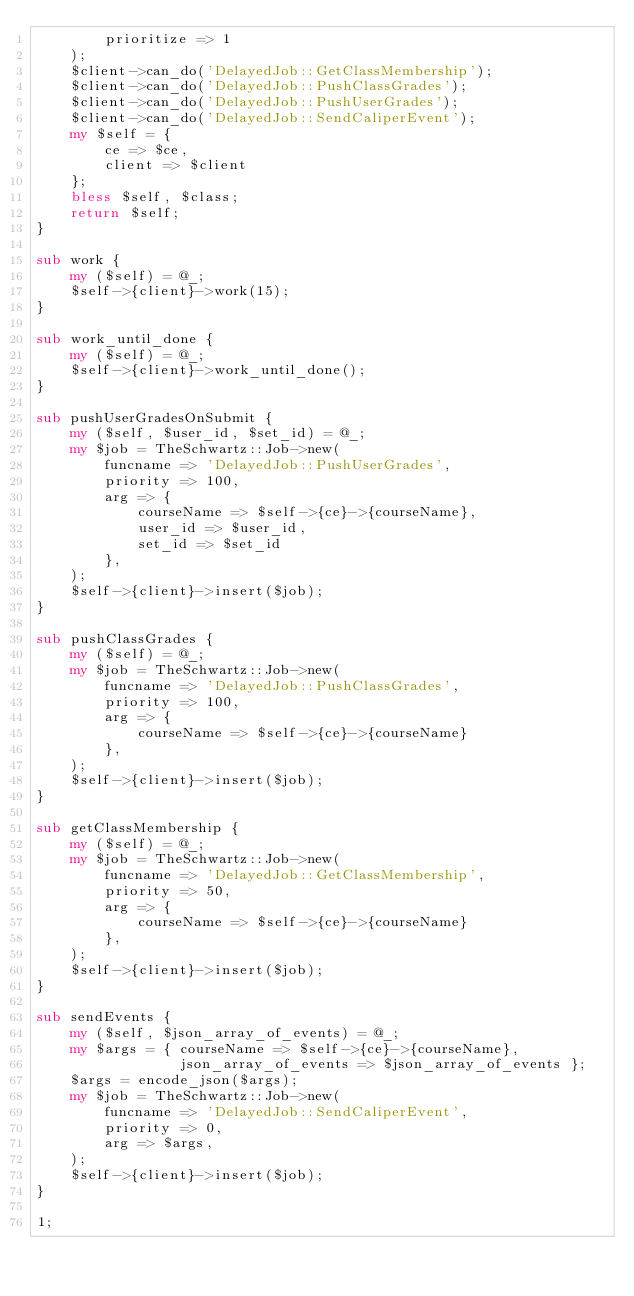<code> <loc_0><loc_0><loc_500><loc_500><_Perl_>        prioritize => 1
    );
    $client->can_do('DelayedJob::GetClassMembership');
    $client->can_do('DelayedJob::PushClassGrades');
    $client->can_do('DelayedJob::PushUserGrades');
    $client->can_do('DelayedJob::SendCaliperEvent');
    my $self = {
        ce => $ce,
        client => $client
    };
    bless $self, $class;
    return $self;
}

sub work {
    my ($self) = @_;
    $self->{client}->work(15);
}

sub work_until_done {
    my ($self) = @_;
    $self->{client}->work_until_done();
}

sub pushUserGradesOnSubmit {
    my ($self, $user_id, $set_id) = @_;
    my $job = TheSchwartz::Job->new(
        funcname => 'DelayedJob::PushUserGrades',
        priority => 100,
        arg => {
            courseName => $self->{ce}->{courseName},
            user_id => $user_id,
            set_id => $set_id
        },
    );
    $self->{client}->insert($job);
}

sub pushClassGrades {
    my ($self) = @_;
    my $job = TheSchwartz::Job->new(
        funcname => 'DelayedJob::PushClassGrades',
        priority => 100,
        arg => {
            courseName => $self->{ce}->{courseName}
        },
    );
    $self->{client}->insert($job);
}

sub getClassMembership {
    my ($self) = @_;
    my $job = TheSchwartz::Job->new(
        funcname => 'DelayedJob::GetClassMembership',
        priority => 50,
        arg => {
            courseName => $self->{ce}->{courseName}
        },
    );
    $self->{client}->insert($job);
}

sub sendEvents {
    my ($self, $json_array_of_events) = @_;
    my $args = { courseName => $self->{ce}->{courseName},
                 json_array_of_events => $json_array_of_events };
    $args = encode_json($args);
    my $job = TheSchwartz::Job->new(
        funcname => 'DelayedJob::SendCaliperEvent',
        priority => 0,
        arg => $args,
    );
    $self->{client}->insert($job);
}

1;
</code> 